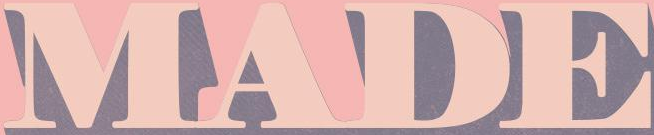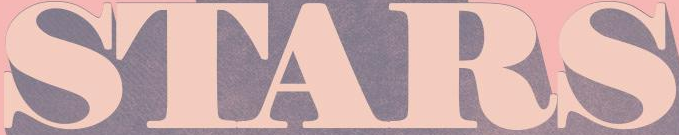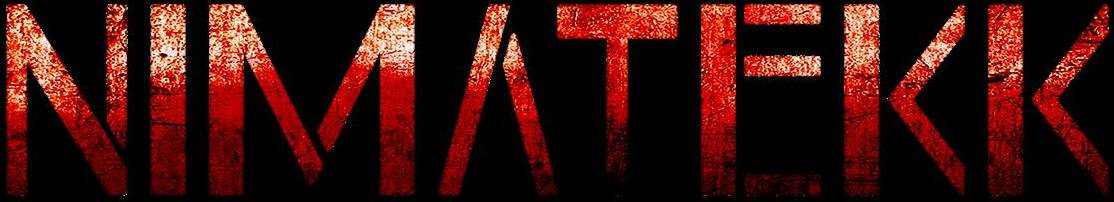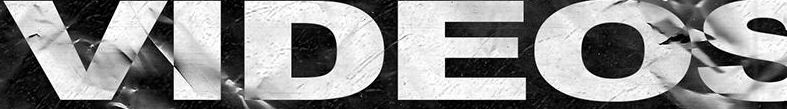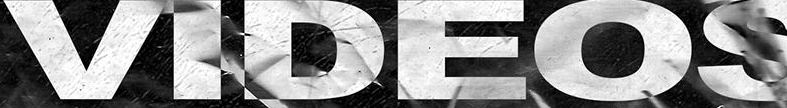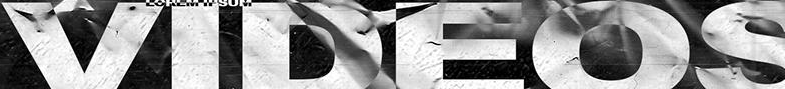What text appears in these images from left to right, separated by a semicolon? MADE; STARS; NIMΛTEKK; VIDEOS; VIDEOS; VIDEOS 